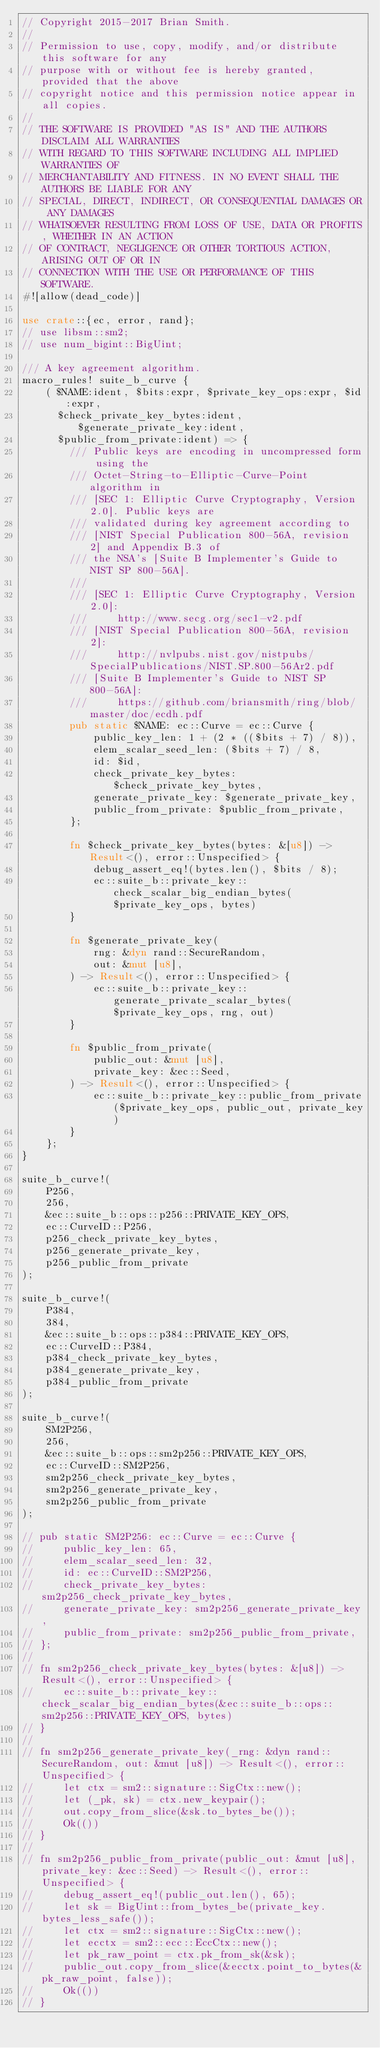Convert code to text. <code><loc_0><loc_0><loc_500><loc_500><_Rust_>// Copyright 2015-2017 Brian Smith.
//
// Permission to use, copy, modify, and/or distribute this software for any
// purpose with or without fee is hereby granted, provided that the above
// copyright notice and this permission notice appear in all copies.
//
// THE SOFTWARE IS PROVIDED "AS IS" AND THE AUTHORS DISCLAIM ALL WARRANTIES
// WITH REGARD TO THIS SOFTWARE INCLUDING ALL IMPLIED WARRANTIES OF
// MERCHANTABILITY AND FITNESS. IN NO EVENT SHALL THE AUTHORS BE LIABLE FOR ANY
// SPECIAL, DIRECT, INDIRECT, OR CONSEQUENTIAL DAMAGES OR ANY DAMAGES
// WHATSOEVER RESULTING FROM LOSS OF USE, DATA OR PROFITS, WHETHER IN AN ACTION
// OF CONTRACT, NEGLIGENCE OR OTHER TORTIOUS ACTION, ARISING OUT OF OR IN
// CONNECTION WITH THE USE OR PERFORMANCE OF THIS SOFTWARE.
#![allow(dead_code)]

use crate::{ec, error, rand};
// use libsm::sm2;
// use num_bigint::BigUint;

/// A key agreement algorithm.
macro_rules! suite_b_curve {
    ( $NAME:ident, $bits:expr, $private_key_ops:expr, $id:expr,
      $check_private_key_bytes:ident, $generate_private_key:ident,
      $public_from_private:ident) => {
        /// Public keys are encoding in uncompressed form using the
        /// Octet-String-to-Elliptic-Curve-Point algorithm in
        /// [SEC 1: Elliptic Curve Cryptography, Version 2.0]. Public keys are
        /// validated during key agreement according to
        /// [NIST Special Publication 800-56A, revision 2] and Appendix B.3 of
        /// the NSA's [Suite B Implementer's Guide to NIST SP 800-56A].
        ///
        /// [SEC 1: Elliptic Curve Cryptography, Version 2.0]:
        ///     http://www.secg.org/sec1-v2.pdf
        /// [NIST Special Publication 800-56A, revision 2]:
        ///     http://nvlpubs.nist.gov/nistpubs/SpecialPublications/NIST.SP.800-56Ar2.pdf
        /// [Suite B Implementer's Guide to NIST SP 800-56A]:
        ///     https://github.com/briansmith/ring/blob/master/doc/ecdh.pdf
        pub static $NAME: ec::Curve = ec::Curve {
            public_key_len: 1 + (2 * (($bits + 7) / 8)),
            elem_scalar_seed_len: ($bits + 7) / 8,
            id: $id,
            check_private_key_bytes: $check_private_key_bytes,
            generate_private_key: $generate_private_key,
            public_from_private: $public_from_private,
        };

        fn $check_private_key_bytes(bytes: &[u8]) -> Result<(), error::Unspecified> {
            debug_assert_eq!(bytes.len(), $bits / 8);
            ec::suite_b::private_key::check_scalar_big_endian_bytes($private_key_ops, bytes)
        }

        fn $generate_private_key(
            rng: &dyn rand::SecureRandom,
            out: &mut [u8],
        ) -> Result<(), error::Unspecified> {
            ec::suite_b::private_key::generate_private_scalar_bytes($private_key_ops, rng, out)
        }

        fn $public_from_private(
            public_out: &mut [u8],
            private_key: &ec::Seed,
        ) -> Result<(), error::Unspecified> {
            ec::suite_b::private_key::public_from_private($private_key_ops, public_out, private_key)
        }
    };
}

suite_b_curve!(
    P256,
    256,
    &ec::suite_b::ops::p256::PRIVATE_KEY_OPS,
    ec::CurveID::P256,
    p256_check_private_key_bytes,
    p256_generate_private_key,
    p256_public_from_private
);

suite_b_curve!(
    P384,
    384,
    &ec::suite_b::ops::p384::PRIVATE_KEY_OPS,
    ec::CurveID::P384,
    p384_check_private_key_bytes,
    p384_generate_private_key,
    p384_public_from_private
);

suite_b_curve!(
    SM2P256,
    256,
    &ec::suite_b::ops::sm2p256::PRIVATE_KEY_OPS,
    ec::CurveID::SM2P256,
    sm2p256_check_private_key_bytes,
    sm2p256_generate_private_key,
    sm2p256_public_from_private
);

// pub static SM2P256: ec::Curve = ec::Curve {
//     public_key_len: 65,
//     elem_scalar_seed_len: 32,
//     id: ec::CurveID::SM2P256,
//     check_private_key_bytes: sm2p256_check_private_key_bytes,
//     generate_private_key: sm2p256_generate_private_key,
//     public_from_private: sm2p256_public_from_private,
// };
//
// fn sm2p256_check_private_key_bytes(bytes: &[u8]) -> Result<(), error::Unspecified> {
//     ec::suite_b::private_key::check_scalar_big_endian_bytes(&ec::suite_b::ops::sm2p256::PRIVATE_KEY_OPS, bytes)
// }
//
// fn sm2p256_generate_private_key(_rng: &dyn rand::SecureRandom, out: &mut [u8]) -> Result<(), error::Unspecified> {
//     let ctx = sm2::signature::SigCtx::new();
//     let (_pk, sk) = ctx.new_keypair();
//     out.copy_from_slice(&sk.to_bytes_be());
//     Ok(())
// }
//
// fn sm2p256_public_from_private(public_out: &mut [u8], private_key: &ec::Seed) -> Result<(), error::Unspecified> {
//     debug_assert_eq!(public_out.len(), 65);
//     let sk = BigUint::from_bytes_be(private_key.bytes_less_safe());
//     let ctx = sm2::signature::SigCtx::new();
//     let ecctx = sm2::ecc::EccCtx::new();
//     let pk_raw_point = ctx.pk_from_sk(&sk);
//     public_out.copy_from_slice(&ecctx.point_to_bytes(&pk_raw_point, false));
//     Ok(())
// }
</code> 